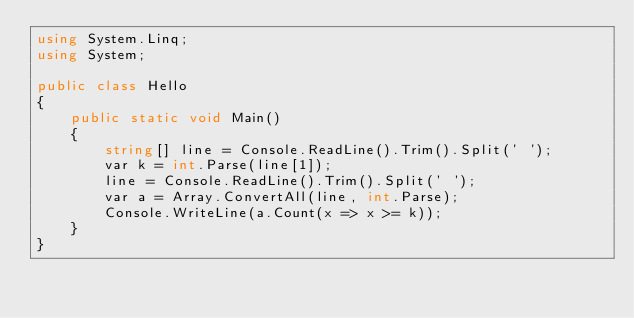<code> <loc_0><loc_0><loc_500><loc_500><_C#_>using System.Linq;
using System;

public class Hello
{
    public static void Main()
    {
        string[] line = Console.ReadLine().Trim().Split(' ');
        var k = int.Parse(line[1]);
        line = Console.ReadLine().Trim().Split(' ');
        var a = Array.ConvertAll(line, int.Parse);
        Console.WriteLine(a.Count(x => x >= k));
    }
}
</code> 